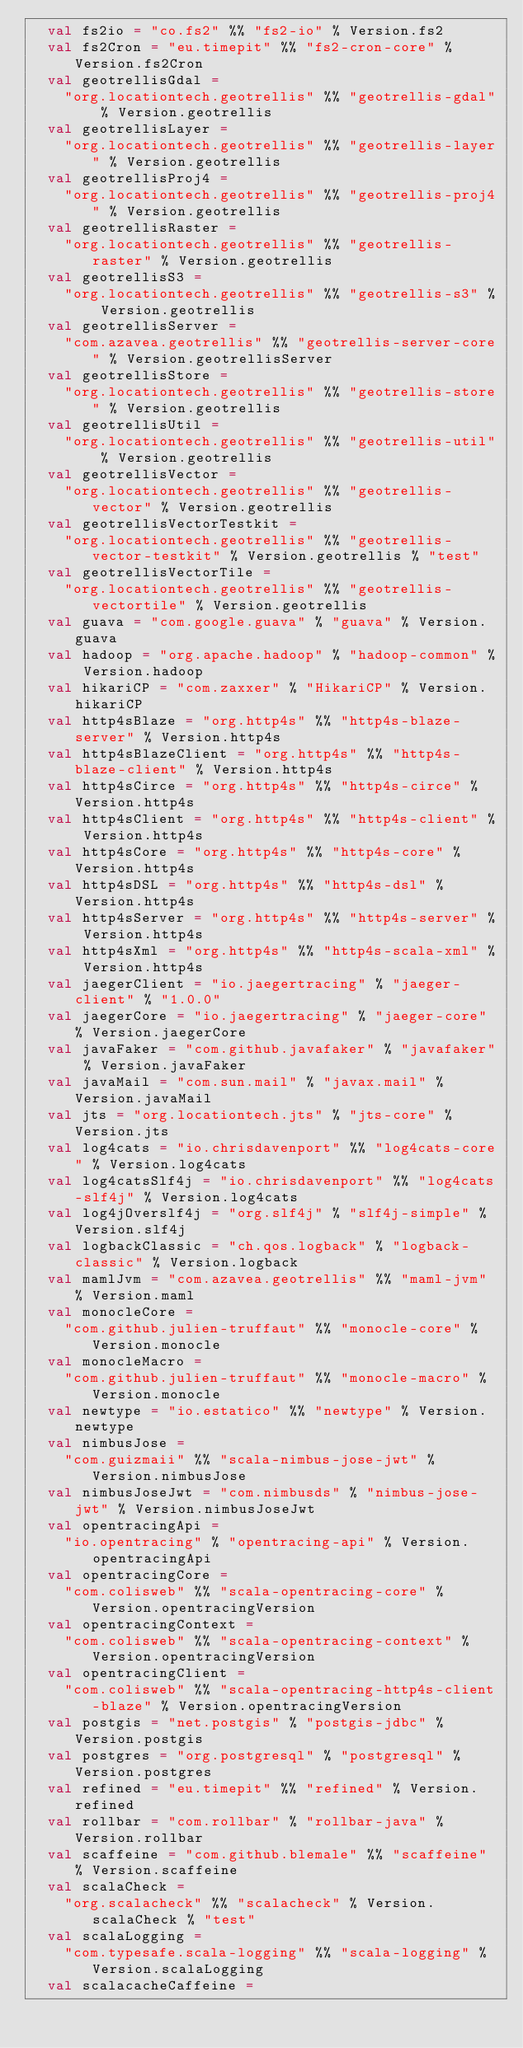<code> <loc_0><loc_0><loc_500><loc_500><_Scala_>  val fs2io = "co.fs2" %% "fs2-io" % Version.fs2
  val fs2Cron = "eu.timepit" %% "fs2-cron-core" % Version.fs2Cron
  val geotrellisGdal =
    "org.locationtech.geotrellis" %% "geotrellis-gdal" % Version.geotrellis
  val geotrellisLayer =
    "org.locationtech.geotrellis" %% "geotrellis-layer" % Version.geotrellis
  val geotrellisProj4 =
    "org.locationtech.geotrellis" %% "geotrellis-proj4" % Version.geotrellis
  val geotrellisRaster =
    "org.locationtech.geotrellis" %% "geotrellis-raster" % Version.geotrellis
  val geotrellisS3 =
    "org.locationtech.geotrellis" %% "geotrellis-s3" % Version.geotrellis
  val geotrellisServer =
    "com.azavea.geotrellis" %% "geotrellis-server-core" % Version.geotrellisServer
  val geotrellisStore =
    "org.locationtech.geotrellis" %% "geotrellis-store" % Version.geotrellis
  val geotrellisUtil =
    "org.locationtech.geotrellis" %% "geotrellis-util" % Version.geotrellis
  val geotrellisVector =
    "org.locationtech.geotrellis" %% "geotrellis-vector" % Version.geotrellis
  val geotrellisVectorTestkit =
    "org.locationtech.geotrellis" %% "geotrellis-vector-testkit" % Version.geotrellis % "test"
  val geotrellisVectorTile =
    "org.locationtech.geotrellis" %% "geotrellis-vectortile" % Version.geotrellis
  val guava = "com.google.guava" % "guava" % Version.guava
  val hadoop = "org.apache.hadoop" % "hadoop-common" % Version.hadoop
  val hikariCP = "com.zaxxer" % "HikariCP" % Version.hikariCP
  val http4sBlaze = "org.http4s" %% "http4s-blaze-server" % Version.http4s
  val http4sBlazeClient = "org.http4s" %% "http4s-blaze-client" % Version.http4s
  val http4sCirce = "org.http4s" %% "http4s-circe" % Version.http4s
  val http4sClient = "org.http4s" %% "http4s-client" % Version.http4s
  val http4sCore = "org.http4s" %% "http4s-core" % Version.http4s
  val http4sDSL = "org.http4s" %% "http4s-dsl" % Version.http4s
  val http4sServer = "org.http4s" %% "http4s-server" % Version.http4s
  val http4sXml = "org.http4s" %% "http4s-scala-xml" % Version.http4s
  val jaegerClient = "io.jaegertracing" % "jaeger-client" % "1.0.0"
  val jaegerCore = "io.jaegertracing" % "jaeger-core" % Version.jaegerCore
  val javaFaker = "com.github.javafaker" % "javafaker" % Version.javaFaker
  val javaMail = "com.sun.mail" % "javax.mail" % Version.javaMail
  val jts = "org.locationtech.jts" % "jts-core" % Version.jts
  val log4cats = "io.chrisdavenport" %% "log4cats-core" % Version.log4cats
  val log4catsSlf4j = "io.chrisdavenport" %% "log4cats-slf4j" % Version.log4cats
  val log4jOverslf4j = "org.slf4j" % "slf4j-simple" % Version.slf4j
  val logbackClassic = "ch.qos.logback" % "logback-classic" % Version.logback
  val mamlJvm = "com.azavea.geotrellis" %% "maml-jvm" % Version.maml
  val monocleCore =
    "com.github.julien-truffaut" %% "monocle-core" % Version.monocle
  val monocleMacro =
    "com.github.julien-truffaut" %% "monocle-macro" % Version.monocle
  val newtype = "io.estatico" %% "newtype" % Version.newtype
  val nimbusJose =
    "com.guizmaii" %% "scala-nimbus-jose-jwt" % Version.nimbusJose
  val nimbusJoseJwt = "com.nimbusds" % "nimbus-jose-jwt" % Version.nimbusJoseJwt
  val opentracingApi =
    "io.opentracing" % "opentracing-api" % Version.opentracingApi
  val opentracingCore =
    "com.colisweb" %% "scala-opentracing-core" % Version.opentracingVersion
  val opentracingContext =
    "com.colisweb" %% "scala-opentracing-context" % Version.opentracingVersion
  val opentracingClient =
    "com.colisweb" %% "scala-opentracing-http4s-client-blaze" % Version.opentracingVersion
  val postgis = "net.postgis" % "postgis-jdbc" % Version.postgis
  val postgres = "org.postgresql" % "postgresql" % Version.postgres
  val refined = "eu.timepit" %% "refined" % Version.refined
  val rollbar = "com.rollbar" % "rollbar-java" % Version.rollbar
  val scaffeine = "com.github.blemale" %% "scaffeine" % Version.scaffeine
  val scalaCheck =
    "org.scalacheck" %% "scalacheck" % Version.scalaCheck % "test"
  val scalaLogging =
    "com.typesafe.scala-logging" %% "scala-logging" % Version.scalaLogging
  val scalacacheCaffeine =</code> 